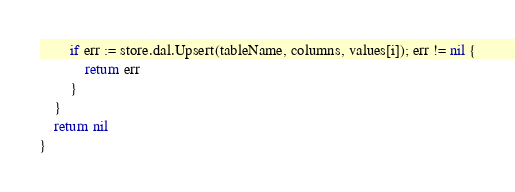<code> <loc_0><loc_0><loc_500><loc_500><_Go_>		if err := store.dal.Upsert(tableName, columns, values[i]); err != nil {
			return err
		}
	}
	return nil
}
</code> 